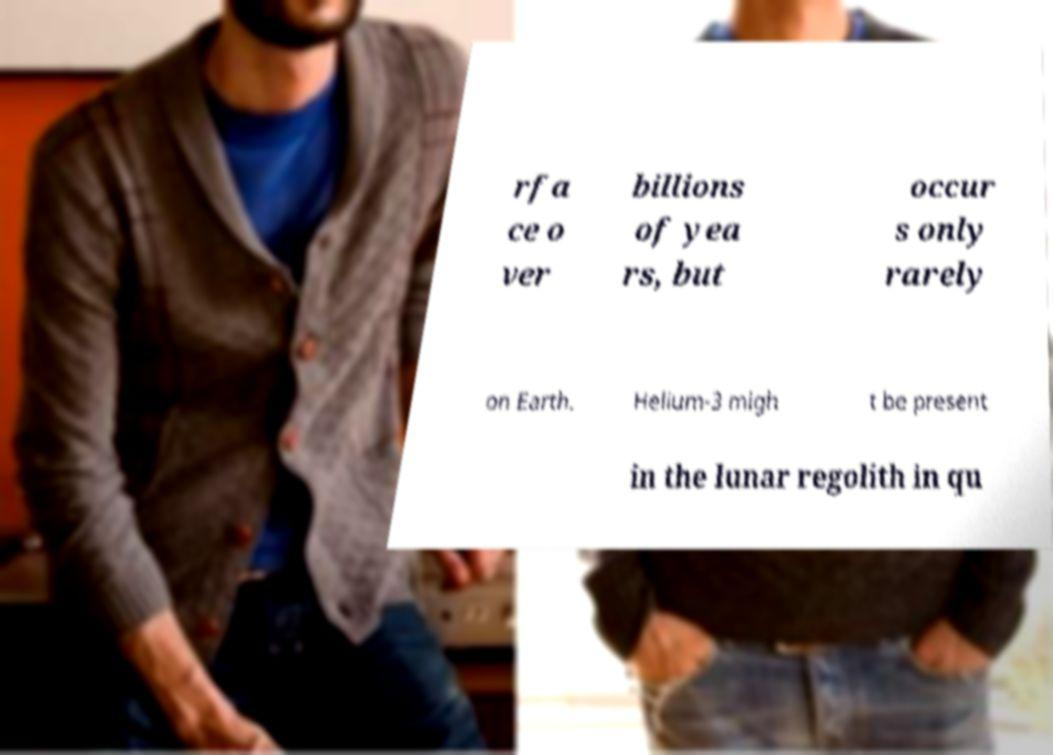What messages or text are displayed in this image? I need them in a readable, typed format. rfa ce o ver billions of yea rs, but occur s only rarely on Earth. Helium-3 migh t be present in the lunar regolith in qu 